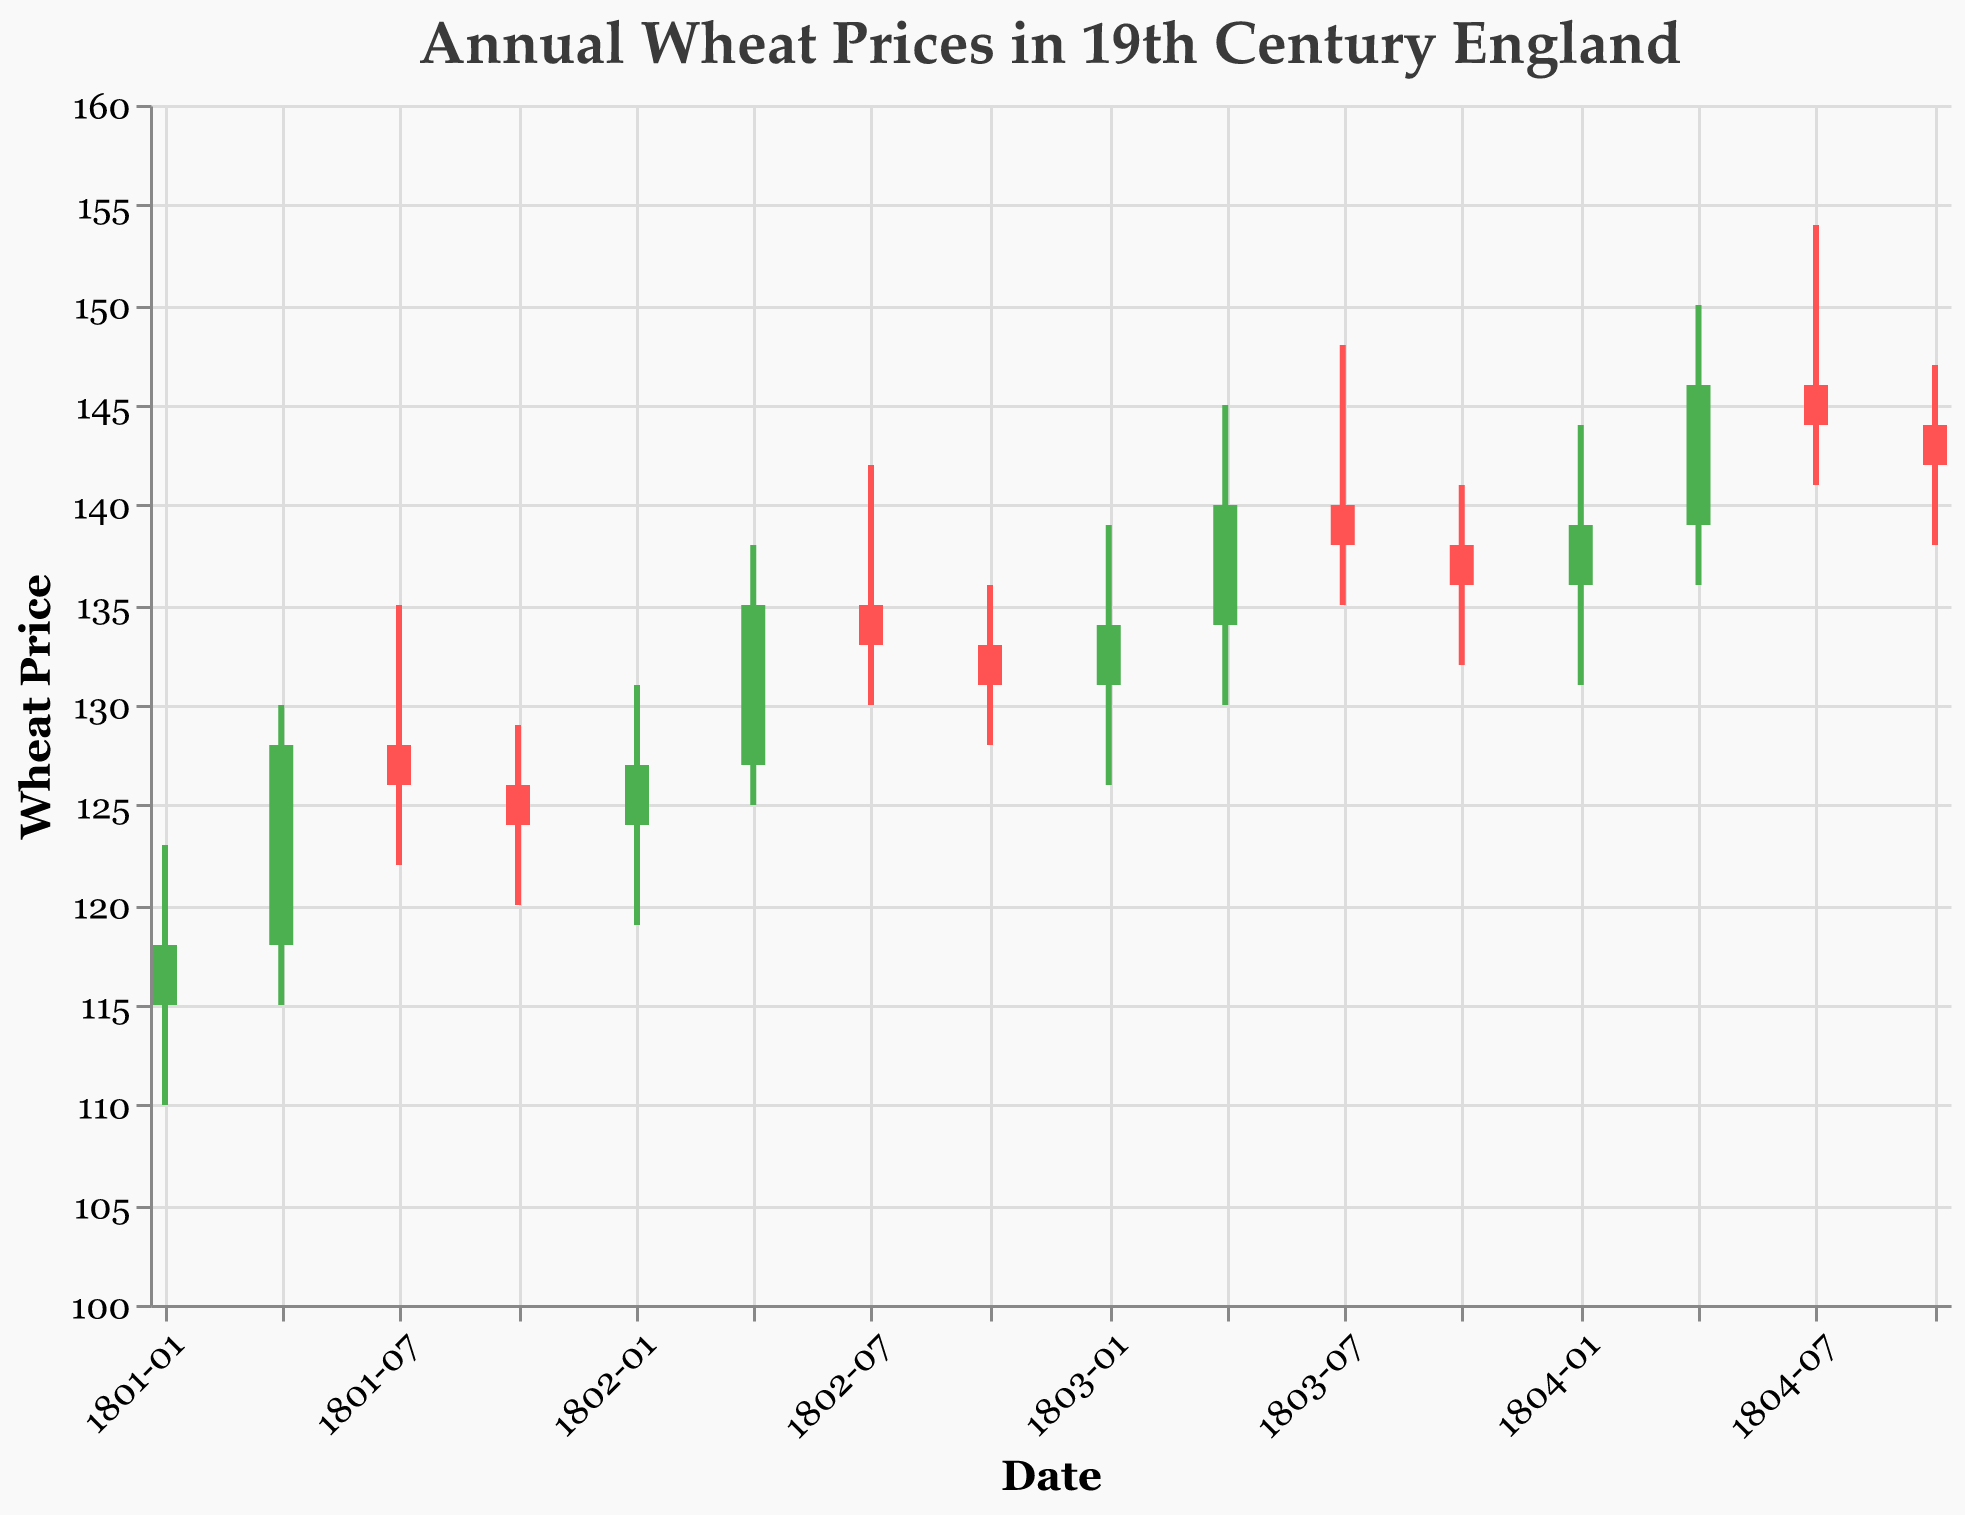What is the title of this figure? The title is located at the top of the figure as textual information. It reads "Annual Wheat Prices in 19th Century England".
Answer: Annual Wheat Prices in 19th Century England In which year and quarter did the wheat price close at 135? Locate the data points in the figure where the 'Close' value is 135. This occurs in the data for the second quarter of 1802.
Answer: 1802, Q2 How many data points are presented in the figure? Count the number of unique data points in the figure. Each quarter for each year is represented, and there are data points from Q1 1801 to Q4 1804, which totals 16 points.
Answer: 16 Which quarter experienced the highest 'High' price and what was it? Identify the data point with the maximum 'High' value in the figure. The highest 'High' value recorded is 154 during the third quarter of 1804.
Answer: 1804, Q3; 154 During which quarter did the 'Low' price reach its lowest, and what was the value? Look for the minimum 'Low' value in the figure. The lowest 'Low' price recorded is 110 in the first quarter of 1801.
Answer: 1801, Q1; 110 Between 1801-1804, which quarter had the highest increase in closing price from the previous quarter? Calculate the difference in 'Close' values between consecutive quarters. The largest increase in 'Close' price occurs between Q1 1801 and Q2 1801, rising from 118 to 128, an increase of 10.
Answer: 1801, Q2 What was the average closing price for the year 1803? Add up the 'Close' values for each quarter of 1803 and divide by the number of quarters. \( (134 + 140 + 138 + 136) / 4 = 137 \)
Answer: 137 Which quarter had the smallest range between the 'High' and 'Low' prices, and what was that range? Compute the range (difference between 'High' and 'Low') for each quarter; the smallest range is between 128 and 136 during Q4 1802 (range of 8).
Answer: 1802, Q4; 8 Between Q1 1802 and Q4 1802, did the closing price increase or decrease, and by how much? Compare the 'Close' price in Q1 1802 (127) with Q4 1802 (131); the closing price increased by 4.
Answer: Increase; 4 During which year was the average opening price the highest, and what was it? Calculate the average 'Open' price for each year, and compare. For 1804: \( (136 + 139 + 146 + 144) / 4 = 141.25 \)
Answer: 1804; 141.25 